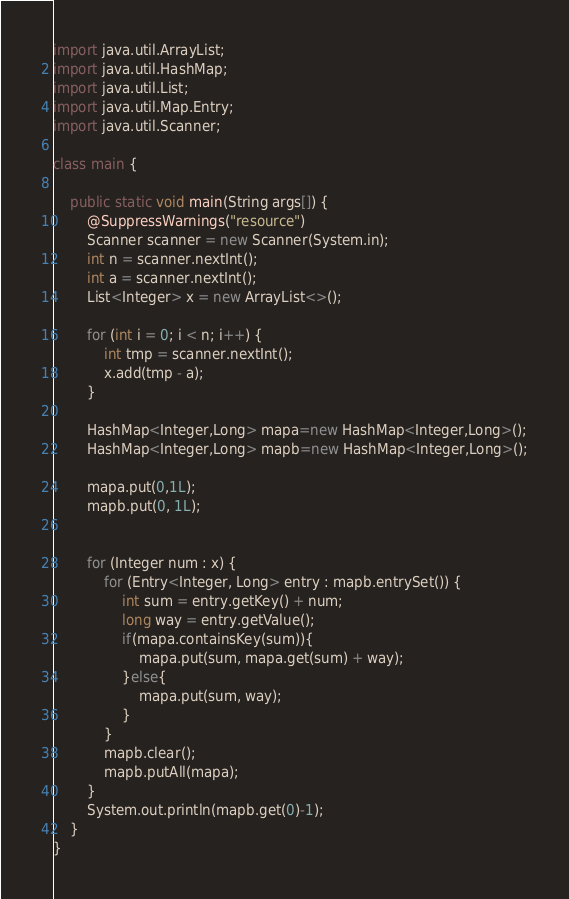Convert code to text. <code><loc_0><loc_0><loc_500><loc_500><_Java_>import java.util.ArrayList;
import java.util.HashMap;
import java.util.List;
import java.util.Map.Entry;
import java.util.Scanner;

class main {

	public static void main(String args[]) {
		@SuppressWarnings("resource")
		Scanner scanner = new Scanner(System.in);
		int n = scanner.nextInt();
		int a = scanner.nextInt();
		List<Integer> x = new ArrayList<>();

		for (int i = 0; i < n; i++) {
			int tmp = scanner.nextInt();
			x.add(tmp - a);
		}
		
		HashMap<Integer,Long> mapa=new HashMap<Integer,Long>();
		HashMap<Integer,Long> mapb=new HashMap<Integer,Long>();
		
		mapa.put(0,1L);
		mapb.put(0, 1L);

		
		for (Integer num : x) {
			for (Entry<Integer, Long> entry : mapb.entrySet()) {
				int sum = entry.getKey() + num;
				long way = entry.getValue();
				if(mapa.containsKey(sum)){
					mapa.put(sum, mapa.get(sum) + way);
				}else{
					mapa.put(sum, way);
				}
			}
			mapb.clear();
			mapb.putAll(mapa);
		}
		System.out.println(mapb.get(0)-1);
	}
}
</code> 